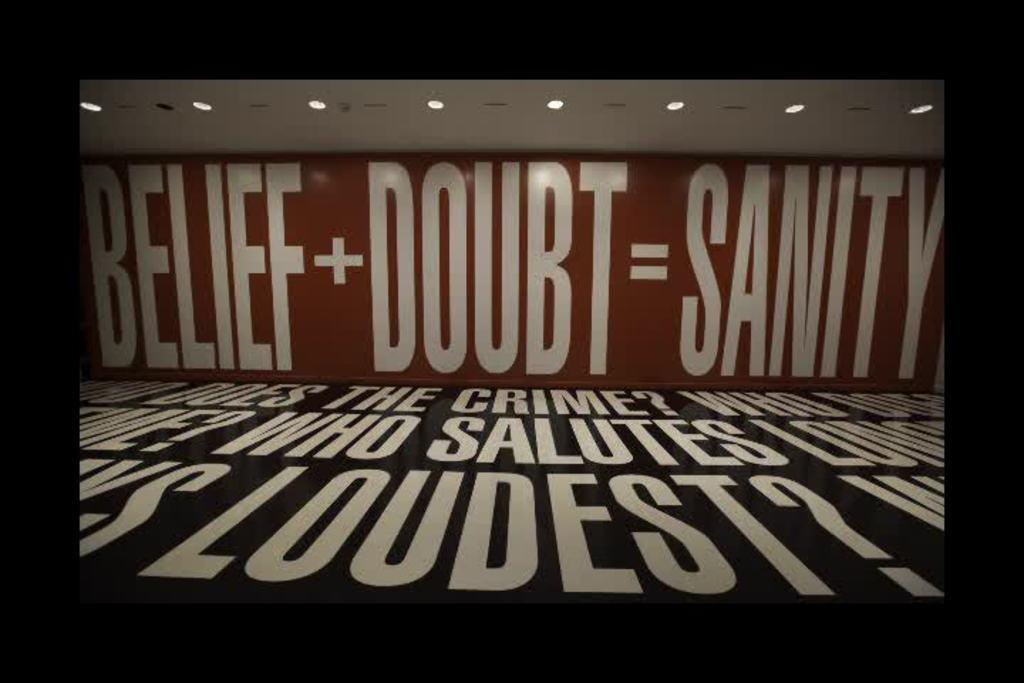<image>
Provide a brief description of the given image. Large painting on a wall that says "Belief+Doubt=Sanity". 